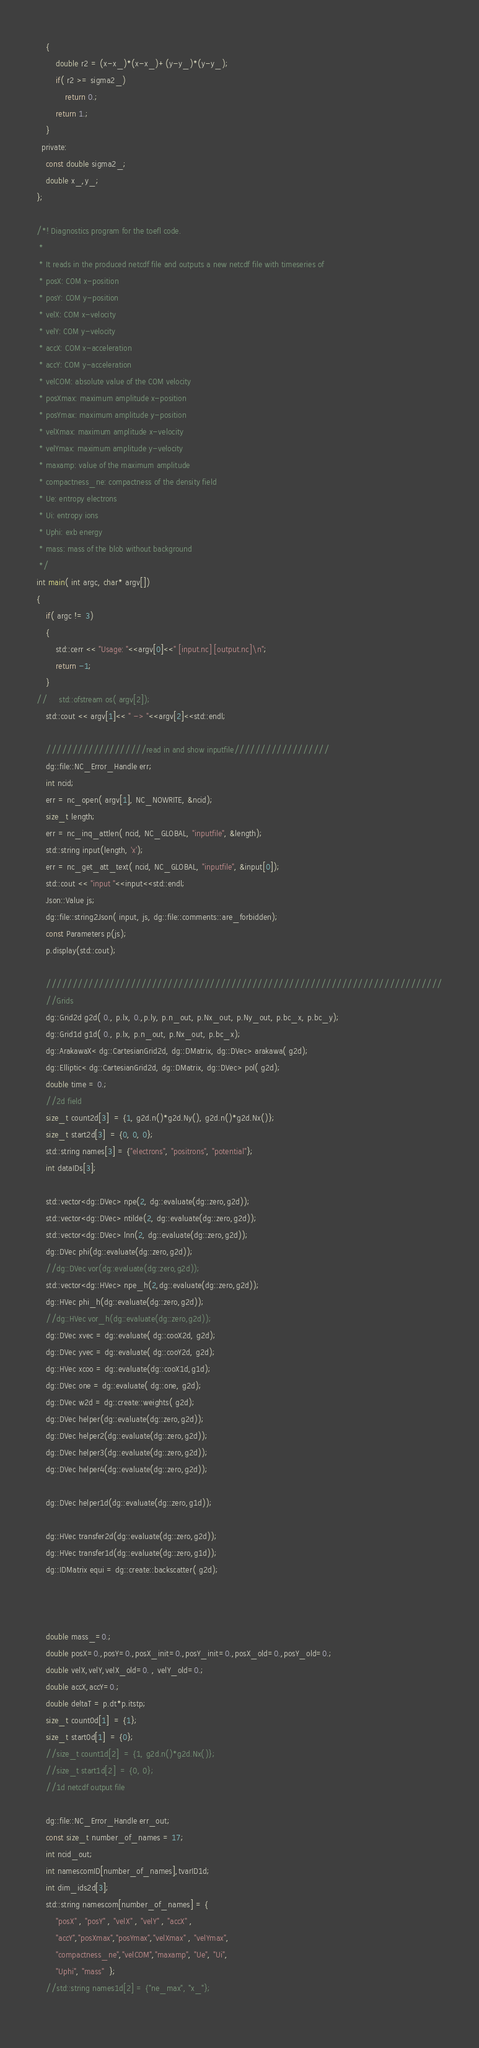Convert code to text. <code><loc_0><loc_0><loc_500><loc_500><_Cuda_>    {
        double r2 = (x-x_)*(x-x_)+(y-y_)*(y-y_);
        if( r2 >= sigma2_)
            return 0.;
        return 1.;
    }
  private:
    const double sigma2_;
    double x_,y_;
};

/*! Diagnostics program for the toefl code. 
 *
 * It reads in the produced netcdf file and outputs a new netcdf file with timeseries of
 * posX: COM x-position
 * posY: COM y-position
 * velX: COM x-velocity
 * velY: COM y-velocity
 * accX: COM x-acceleration
 * accY: COM y-acceleration
 * velCOM: absolute value of the COM velocity
 * posXmax: maximum amplitude x-position
 * posYmax: maximum amplitude y-position
 * velXmax: maximum amplitude x-velocity
 * velYmax: maximum amplitude y-velocity
 * maxamp: value of the maximum amplitude
 * compactness_ne: compactness of the density field
 * Ue: entropy electrons
 * Ui: entropy ions
 * Uphi: exb energy
 * mass: mass of the blob without background
 */
int main( int argc, char* argv[])
{
    if( argc != 3)
    {
        std::cerr << "Usage: "<<argv[0]<<" [input.nc] [output.nc]\n";
        return -1;
    }
//     std::ofstream os( argv[2]);
    std::cout << argv[1]<< " -> "<<argv[2]<<std::endl;

    ///////////////////read in and show inputfile//////////////////
    dg::file::NC_Error_Handle err;
    int ncid;
    err = nc_open( argv[1], NC_NOWRITE, &ncid);
    size_t length;
    err = nc_inq_attlen( ncid, NC_GLOBAL, "inputfile", &length);
    std::string input(length, 'x');
    err = nc_get_att_text( ncid, NC_GLOBAL, "inputfile", &input[0]);
    std::cout << "input "<<input<<std::endl;
    Json::Value js;
    dg::file::string2Json( input, js, dg::file::comments::are_forbidden);
    const Parameters p(js);
    p.display(std::cout);
    
    ///////////////////////////////////////////////////////////////////////////
    //Grids
    dg::Grid2d g2d( 0., p.lx, 0.,p.ly, p.n_out, p.Nx_out, p.Ny_out, p.bc_x, p.bc_y);
    dg::Grid1d g1d( 0., p.lx, p.n_out, p.Nx_out, p.bc_x);
    dg::ArakawaX< dg::CartesianGrid2d, dg::DMatrix, dg::DVec> arakawa( g2d); 
    dg::Elliptic< dg::CartesianGrid2d, dg::DMatrix, dg::DVec> pol( g2d); 
    double time = 0.;
    //2d field
    size_t count2d[3]  = {1, g2d.n()*g2d.Ny(), g2d.n()*g2d.Nx()};
    size_t start2d[3]  = {0, 0, 0};
    std::string names[3] = {"electrons", "positrons", "potential"}; 
    int dataIDs[3];
  
    std::vector<dg::DVec> npe(2, dg::evaluate(dg::zero,g2d));
    std::vector<dg::DVec> ntilde(2, dg::evaluate(dg::zero,g2d));
    std::vector<dg::DVec> lnn(2, dg::evaluate(dg::zero,g2d));
    dg::DVec phi(dg::evaluate(dg::zero,g2d));
    //dg::DVec vor(dg::evaluate(dg::zero,g2d));
    std::vector<dg::HVec> npe_h(2,dg::evaluate(dg::zero,g2d));
    dg::HVec phi_h(dg::evaluate(dg::zero,g2d));
    //dg::HVec vor_h(dg::evaluate(dg::zero,g2d));
    dg::DVec xvec = dg::evaluate( dg::cooX2d, g2d);
    dg::DVec yvec = dg::evaluate( dg::cooY2d, g2d);
    dg::HVec xcoo = dg::evaluate(dg::cooX1d,g1d);
    dg::DVec one = dg::evaluate( dg::one, g2d);
    dg::DVec w2d = dg::create::weights( g2d);
    dg::DVec helper(dg::evaluate(dg::zero,g2d));
    dg::DVec helper2(dg::evaluate(dg::zero,g2d));
    dg::DVec helper3(dg::evaluate(dg::zero,g2d));
    dg::DVec helper4(dg::evaluate(dg::zero,g2d));

    dg::DVec helper1d(dg::evaluate(dg::zero,g1d));
    
    dg::HVec transfer2d(dg::evaluate(dg::zero,g2d));
    dg::HVec transfer1d(dg::evaluate(dg::zero,g1d));
    dg::IDMatrix equi = dg::create::backscatter( g2d);


    
    double mass_=0.;
    double posX=0.,posY=0.,posX_init=0.,posY_init=0.,posX_old=0.,posY_old=0.;
    double velX,velY,velX_old=0. , velY_old=0.;    
    double accX,accY=0.;
    double deltaT = p.dt*p.itstp;
    size_t count0d[1]  = {1};
    size_t start0d[1]  = {0};    
    //size_t count1d[2]  = {1, g2d.n()*g2d.Nx()};
    //size_t start1d[2]  = {0, 0};    
    //1d netcdf output file    

    dg::file::NC_Error_Handle err_out;
    const size_t number_of_names = 17;
    int ncid_out;
    int namescomID[number_of_names],tvarID1d;
    int dim_ids2d[3];
    std::string namescom[number_of_names] = {
        "posX" , "posY" , "velX" , "velY" , "accX" , 
        "accY","posXmax","posYmax","velXmax" , "velYmax",
        "compactness_ne","velCOM","maxamp", "Ue", "Ui", 
        "Uphi", "mass"  };
    //std::string names1d[2] = {"ne_max", "x_"};
    </code> 